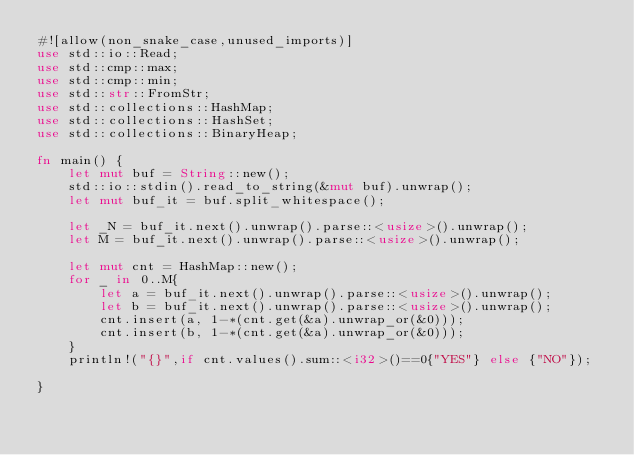Convert code to text. <code><loc_0><loc_0><loc_500><loc_500><_Rust_>#![allow(non_snake_case,unused_imports)]
use std::io::Read;
use std::cmp::max;
use std::cmp::min;
use std::str::FromStr;
use std::collections::HashMap;
use std::collections::HashSet;
use std::collections::BinaryHeap;

fn main() {
    let mut buf = String::new();
    std::io::stdin().read_to_string(&mut buf).unwrap();
    let mut buf_it = buf.split_whitespace();

    let _N = buf_it.next().unwrap().parse::<usize>().unwrap();
    let M = buf_it.next().unwrap().parse::<usize>().unwrap();

    let mut cnt = HashMap::new();
    for _ in 0..M{
        let a = buf_it.next().unwrap().parse::<usize>().unwrap();
        let b = buf_it.next().unwrap().parse::<usize>().unwrap();
        cnt.insert(a, 1-*(cnt.get(&a).unwrap_or(&0)));
        cnt.insert(b, 1-*(cnt.get(&a).unwrap_or(&0)));
    }
    println!("{}",if cnt.values().sum::<i32>()==0{"YES"} else {"NO"});

}
</code> 